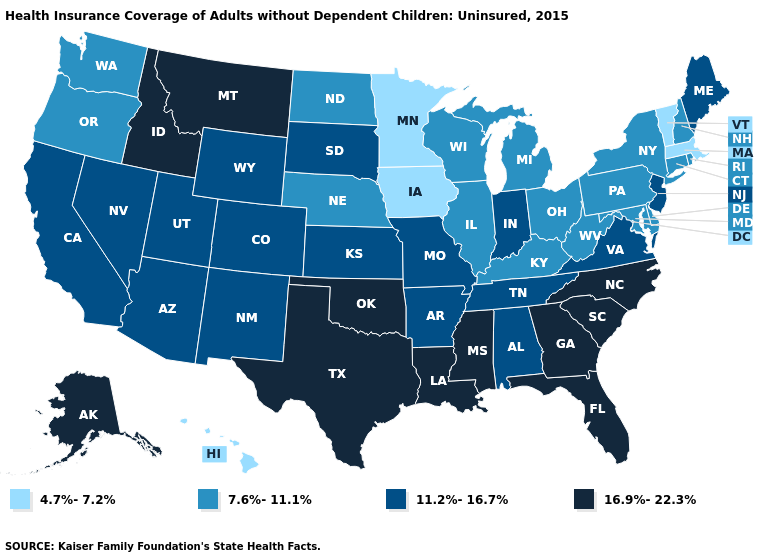How many symbols are there in the legend?
Answer briefly. 4. Does Minnesota have the same value as Wisconsin?
Concise answer only. No. Name the states that have a value in the range 4.7%-7.2%?
Be succinct. Hawaii, Iowa, Massachusetts, Minnesota, Vermont. What is the highest value in the MidWest ?
Short answer required. 11.2%-16.7%. Does Mississippi have the highest value in the USA?
Be succinct. Yes. Name the states that have a value in the range 16.9%-22.3%?
Concise answer only. Alaska, Florida, Georgia, Idaho, Louisiana, Mississippi, Montana, North Carolina, Oklahoma, South Carolina, Texas. What is the value of Nevada?
Concise answer only. 11.2%-16.7%. Name the states that have a value in the range 16.9%-22.3%?
Concise answer only. Alaska, Florida, Georgia, Idaho, Louisiana, Mississippi, Montana, North Carolina, Oklahoma, South Carolina, Texas. Does New Hampshire have a lower value than Ohio?
Concise answer only. No. What is the value of Tennessee?
Quick response, please. 11.2%-16.7%. Does the first symbol in the legend represent the smallest category?
Be succinct. Yes. Among the states that border Nevada , which have the lowest value?
Answer briefly. Oregon. Does Virginia have the highest value in the USA?
Be succinct. No. What is the highest value in the West ?
Keep it brief. 16.9%-22.3%. What is the lowest value in the USA?
Keep it brief. 4.7%-7.2%. 